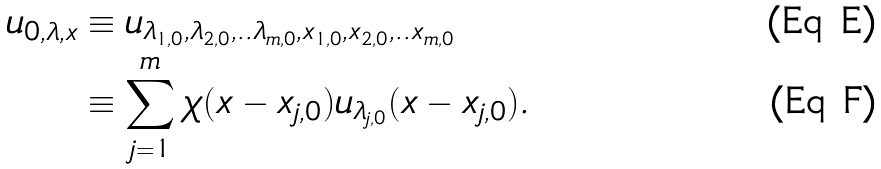<formula> <loc_0><loc_0><loc_500><loc_500>u _ { 0 , \lambda , x } & \equiv u _ { \lambda _ { 1 , 0 } , \lambda _ { 2 , 0 } , . . \lambda _ { m , 0 } , x _ { 1 , 0 } , x _ { 2 , 0 } , . . x _ { m , 0 } } \\ & \equiv \sum _ { j = 1 } ^ { m } \chi ( x - x _ { j , 0 } ) u _ { \lambda _ { j , 0 } } ( x - x _ { j , 0 } ) .</formula> 